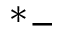Convert formula to latex. <formula><loc_0><loc_0><loc_500><loc_500>^ { * } -</formula> 